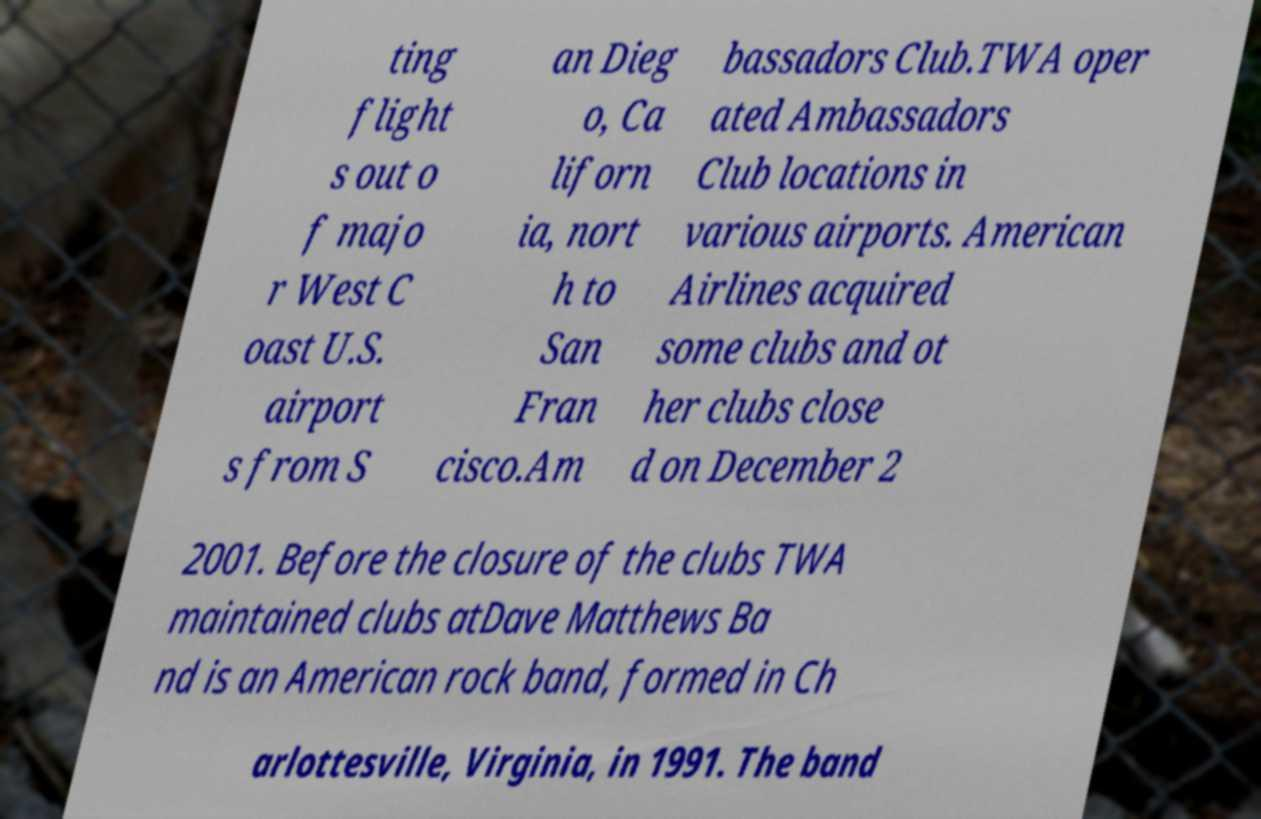There's text embedded in this image that I need extracted. Can you transcribe it verbatim? ting flight s out o f majo r West C oast U.S. airport s from S an Dieg o, Ca liforn ia, nort h to San Fran cisco.Am bassadors Club.TWA oper ated Ambassadors Club locations in various airports. American Airlines acquired some clubs and ot her clubs close d on December 2 2001. Before the closure of the clubs TWA maintained clubs atDave Matthews Ba nd is an American rock band, formed in Ch arlottesville, Virginia, in 1991. The band 